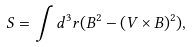Convert formula to latex. <formula><loc_0><loc_0><loc_500><loc_500>S = \int d ^ { 3 } r ( B ^ { 2 } - ( { V } \times { B } ) ^ { 2 } ) ,</formula> 